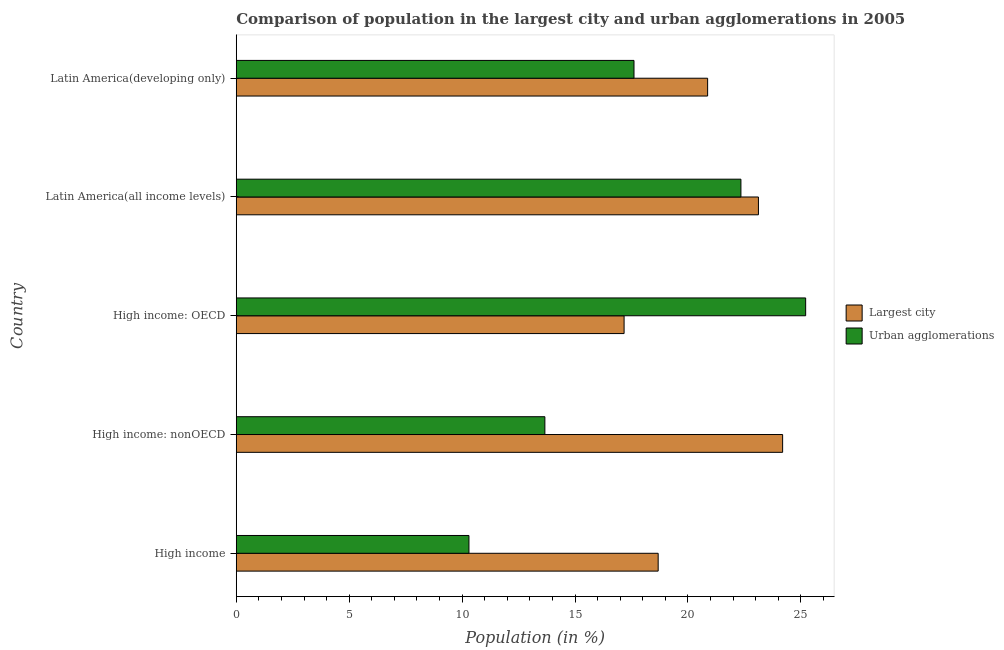How many groups of bars are there?
Make the answer very short. 5. Are the number of bars per tick equal to the number of legend labels?
Provide a short and direct response. Yes. What is the label of the 1st group of bars from the top?
Your answer should be very brief. Latin America(developing only). What is the population in the largest city in High income?
Offer a very short reply. 18.68. Across all countries, what is the maximum population in the largest city?
Make the answer very short. 24.19. Across all countries, what is the minimum population in the largest city?
Provide a succinct answer. 17.17. In which country was the population in urban agglomerations maximum?
Offer a very short reply. High income: OECD. In which country was the population in the largest city minimum?
Your answer should be very brief. High income: OECD. What is the total population in the largest city in the graph?
Offer a very short reply. 104.04. What is the difference between the population in urban agglomerations in High income: OECD and that in High income: nonOECD?
Provide a succinct answer. 11.55. What is the difference between the population in the largest city in High income: OECD and the population in urban agglomerations in High income: nonOECD?
Your response must be concise. 3.51. What is the average population in urban agglomerations per country?
Provide a short and direct response. 17.83. What is the difference between the population in the largest city and population in urban agglomerations in Latin America(all income levels)?
Provide a short and direct response. 0.78. In how many countries, is the population in urban agglomerations greater than 19 %?
Keep it short and to the point. 2. What is the ratio of the population in the largest city in High income: nonOECD to that in Latin America(developing only)?
Give a very brief answer. 1.16. What is the difference between the highest and the second highest population in the largest city?
Offer a very short reply. 1.07. What is the difference between the highest and the lowest population in urban agglomerations?
Provide a succinct answer. 14.91. In how many countries, is the population in urban agglomerations greater than the average population in urban agglomerations taken over all countries?
Make the answer very short. 2. Is the sum of the population in urban agglomerations in High income: OECD and Latin America(developing only) greater than the maximum population in the largest city across all countries?
Your answer should be very brief. Yes. What does the 1st bar from the top in Latin America(all income levels) represents?
Provide a succinct answer. Urban agglomerations. What does the 1st bar from the bottom in High income: OECD represents?
Give a very brief answer. Largest city. How many bars are there?
Offer a terse response. 10. How many countries are there in the graph?
Provide a succinct answer. 5. What is the difference between two consecutive major ticks on the X-axis?
Your answer should be very brief. 5. Does the graph contain any zero values?
Offer a very short reply. No. Does the graph contain grids?
Offer a terse response. No. Where does the legend appear in the graph?
Give a very brief answer. Center right. What is the title of the graph?
Keep it short and to the point. Comparison of population in the largest city and urban agglomerations in 2005. What is the label or title of the Y-axis?
Offer a very short reply. Country. What is the Population (in %) in Largest city in High income?
Your response must be concise. 18.68. What is the Population (in %) in Urban agglomerations in High income?
Keep it short and to the point. 10.3. What is the Population (in %) of Largest city in High income: nonOECD?
Your response must be concise. 24.19. What is the Population (in %) of Urban agglomerations in High income: nonOECD?
Keep it short and to the point. 13.66. What is the Population (in %) of Largest city in High income: OECD?
Your answer should be very brief. 17.17. What is the Population (in %) in Urban agglomerations in High income: OECD?
Provide a succinct answer. 25.21. What is the Population (in %) of Largest city in Latin America(all income levels)?
Make the answer very short. 23.12. What is the Population (in %) in Urban agglomerations in Latin America(all income levels)?
Your response must be concise. 22.35. What is the Population (in %) in Largest city in Latin America(developing only)?
Give a very brief answer. 20.87. What is the Population (in %) in Urban agglomerations in Latin America(developing only)?
Keep it short and to the point. 17.61. Across all countries, what is the maximum Population (in %) of Largest city?
Provide a succinct answer. 24.19. Across all countries, what is the maximum Population (in %) of Urban agglomerations?
Your response must be concise. 25.21. Across all countries, what is the minimum Population (in %) of Largest city?
Provide a short and direct response. 17.17. Across all countries, what is the minimum Population (in %) of Urban agglomerations?
Give a very brief answer. 10.3. What is the total Population (in %) of Largest city in the graph?
Offer a very short reply. 104.04. What is the total Population (in %) in Urban agglomerations in the graph?
Give a very brief answer. 89.14. What is the difference between the Population (in %) of Largest city in High income and that in High income: nonOECD?
Your answer should be very brief. -5.51. What is the difference between the Population (in %) in Urban agglomerations in High income and that in High income: nonOECD?
Ensure brevity in your answer.  -3.36. What is the difference between the Population (in %) in Largest city in High income and that in High income: OECD?
Your answer should be compact. 1.51. What is the difference between the Population (in %) in Urban agglomerations in High income and that in High income: OECD?
Give a very brief answer. -14.91. What is the difference between the Population (in %) of Largest city in High income and that in Latin America(all income levels)?
Your answer should be very brief. -4.44. What is the difference between the Population (in %) of Urban agglomerations in High income and that in Latin America(all income levels)?
Your answer should be compact. -12.04. What is the difference between the Population (in %) of Largest city in High income and that in Latin America(developing only)?
Provide a short and direct response. -2.19. What is the difference between the Population (in %) of Urban agglomerations in High income and that in Latin America(developing only)?
Your answer should be compact. -7.31. What is the difference between the Population (in %) of Largest city in High income: nonOECD and that in High income: OECD?
Give a very brief answer. 7.02. What is the difference between the Population (in %) of Urban agglomerations in High income: nonOECD and that in High income: OECD?
Offer a terse response. -11.55. What is the difference between the Population (in %) of Largest city in High income: nonOECD and that in Latin America(all income levels)?
Your answer should be very brief. 1.07. What is the difference between the Population (in %) of Urban agglomerations in High income: nonOECD and that in Latin America(all income levels)?
Ensure brevity in your answer.  -8.68. What is the difference between the Population (in %) in Largest city in High income: nonOECD and that in Latin America(developing only)?
Offer a terse response. 3.32. What is the difference between the Population (in %) of Urban agglomerations in High income: nonOECD and that in Latin America(developing only)?
Give a very brief answer. -3.95. What is the difference between the Population (in %) of Largest city in High income: OECD and that in Latin America(all income levels)?
Provide a succinct answer. -5.95. What is the difference between the Population (in %) of Urban agglomerations in High income: OECD and that in Latin America(all income levels)?
Give a very brief answer. 2.87. What is the difference between the Population (in %) of Largest city in High income: OECD and that in Latin America(developing only)?
Give a very brief answer. -3.7. What is the difference between the Population (in %) in Urban agglomerations in High income: OECD and that in Latin America(developing only)?
Your response must be concise. 7.6. What is the difference between the Population (in %) in Largest city in Latin America(all income levels) and that in Latin America(developing only)?
Ensure brevity in your answer.  2.25. What is the difference between the Population (in %) of Urban agglomerations in Latin America(all income levels) and that in Latin America(developing only)?
Offer a very short reply. 4.73. What is the difference between the Population (in %) of Largest city in High income and the Population (in %) of Urban agglomerations in High income: nonOECD?
Your response must be concise. 5.02. What is the difference between the Population (in %) in Largest city in High income and the Population (in %) in Urban agglomerations in High income: OECD?
Ensure brevity in your answer.  -6.53. What is the difference between the Population (in %) of Largest city in High income and the Population (in %) of Urban agglomerations in Latin America(all income levels)?
Your answer should be very brief. -3.66. What is the difference between the Population (in %) of Largest city in High income and the Population (in %) of Urban agglomerations in Latin America(developing only)?
Your answer should be compact. 1.07. What is the difference between the Population (in %) of Largest city in High income: nonOECD and the Population (in %) of Urban agglomerations in High income: OECD?
Offer a very short reply. -1.02. What is the difference between the Population (in %) in Largest city in High income: nonOECD and the Population (in %) in Urban agglomerations in Latin America(all income levels)?
Ensure brevity in your answer.  1.85. What is the difference between the Population (in %) of Largest city in High income: nonOECD and the Population (in %) of Urban agglomerations in Latin America(developing only)?
Your answer should be compact. 6.58. What is the difference between the Population (in %) of Largest city in High income: OECD and the Population (in %) of Urban agglomerations in Latin America(all income levels)?
Your response must be concise. -5.17. What is the difference between the Population (in %) of Largest city in High income: OECD and the Population (in %) of Urban agglomerations in Latin America(developing only)?
Make the answer very short. -0.44. What is the difference between the Population (in %) of Largest city in Latin America(all income levels) and the Population (in %) of Urban agglomerations in Latin America(developing only)?
Offer a very short reply. 5.51. What is the average Population (in %) of Largest city per country?
Provide a succinct answer. 20.81. What is the average Population (in %) of Urban agglomerations per country?
Keep it short and to the point. 17.83. What is the difference between the Population (in %) of Largest city and Population (in %) of Urban agglomerations in High income?
Give a very brief answer. 8.38. What is the difference between the Population (in %) of Largest city and Population (in %) of Urban agglomerations in High income: nonOECD?
Provide a succinct answer. 10.53. What is the difference between the Population (in %) of Largest city and Population (in %) of Urban agglomerations in High income: OECD?
Your answer should be compact. -8.04. What is the difference between the Population (in %) of Largest city and Population (in %) of Urban agglomerations in Latin America(all income levels)?
Your response must be concise. 0.78. What is the difference between the Population (in %) in Largest city and Population (in %) in Urban agglomerations in Latin America(developing only)?
Provide a short and direct response. 3.26. What is the ratio of the Population (in %) of Largest city in High income to that in High income: nonOECD?
Your answer should be very brief. 0.77. What is the ratio of the Population (in %) in Urban agglomerations in High income to that in High income: nonOECD?
Offer a very short reply. 0.75. What is the ratio of the Population (in %) in Largest city in High income to that in High income: OECD?
Your response must be concise. 1.09. What is the ratio of the Population (in %) in Urban agglomerations in High income to that in High income: OECD?
Offer a very short reply. 0.41. What is the ratio of the Population (in %) in Largest city in High income to that in Latin America(all income levels)?
Keep it short and to the point. 0.81. What is the ratio of the Population (in %) of Urban agglomerations in High income to that in Latin America(all income levels)?
Your answer should be compact. 0.46. What is the ratio of the Population (in %) in Largest city in High income to that in Latin America(developing only)?
Your answer should be compact. 0.9. What is the ratio of the Population (in %) in Urban agglomerations in High income to that in Latin America(developing only)?
Provide a short and direct response. 0.58. What is the ratio of the Population (in %) of Largest city in High income: nonOECD to that in High income: OECD?
Give a very brief answer. 1.41. What is the ratio of the Population (in %) in Urban agglomerations in High income: nonOECD to that in High income: OECD?
Offer a terse response. 0.54. What is the ratio of the Population (in %) of Largest city in High income: nonOECD to that in Latin America(all income levels)?
Keep it short and to the point. 1.05. What is the ratio of the Population (in %) of Urban agglomerations in High income: nonOECD to that in Latin America(all income levels)?
Give a very brief answer. 0.61. What is the ratio of the Population (in %) in Largest city in High income: nonOECD to that in Latin America(developing only)?
Ensure brevity in your answer.  1.16. What is the ratio of the Population (in %) of Urban agglomerations in High income: nonOECD to that in Latin America(developing only)?
Keep it short and to the point. 0.78. What is the ratio of the Population (in %) of Largest city in High income: OECD to that in Latin America(all income levels)?
Give a very brief answer. 0.74. What is the ratio of the Population (in %) in Urban agglomerations in High income: OECD to that in Latin America(all income levels)?
Ensure brevity in your answer.  1.13. What is the ratio of the Population (in %) of Largest city in High income: OECD to that in Latin America(developing only)?
Ensure brevity in your answer.  0.82. What is the ratio of the Population (in %) in Urban agglomerations in High income: OECD to that in Latin America(developing only)?
Offer a very short reply. 1.43. What is the ratio of the Population (in %) in Largest city in Latin America(all income levels) to that in Latin America(developing only)?
Your answer should be very brief. 1.11. What is the ratio of the Population (in %) of Urban agglomerations in Latin America(all income levels) to that in Latin America(developing only)?
Ensure brevity in your answer.  1.27. What is the difference between the highest and the second highest Population (in %) of Largest city?
Keep it short and to the point. 1.07. What is the difference between the highest and the second highest Population (in %) in Urban agglomerations?
Offer a terse response. 2.87. What is the difference between the highest and the lowest Population (in %) in Largest city?
Your answer should be very brief. 7.02. What is the difference between the highest and the lowest Population (in %) of Urban agglomerations?
Your answer should be very brief. 14.91. 